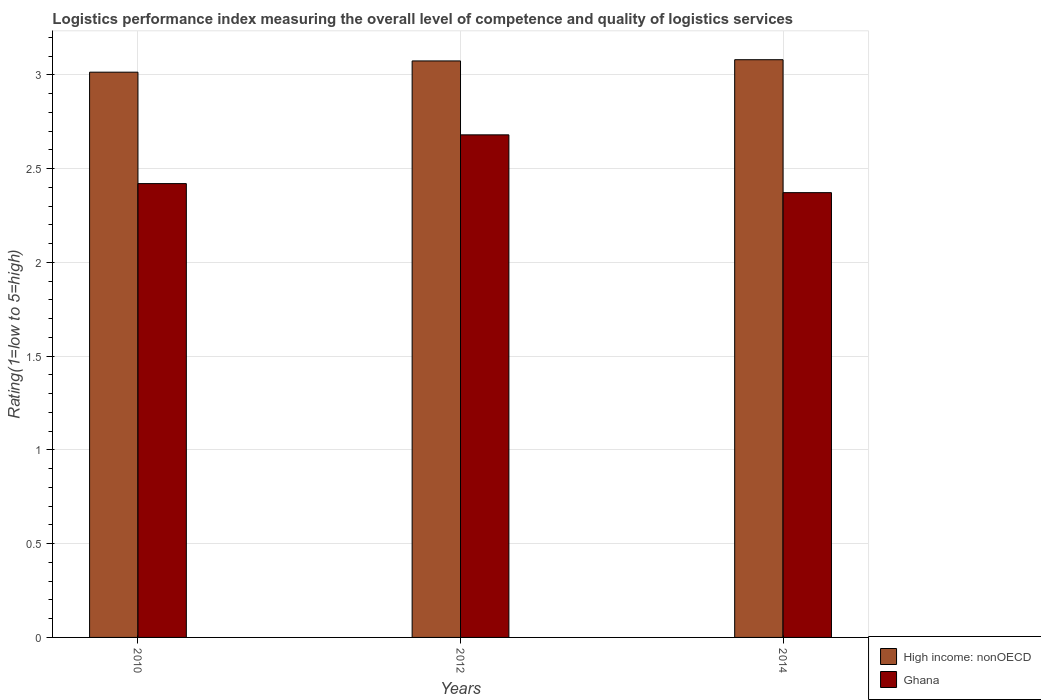Are the number of bars per tick equal to the number of legend labels?
Give a very brief answer. Yes. What is the Logistic performance index in High income: nonOECD in 2010?
Offer a very short reply. 3.01. Across all years, what is the maximum Logistic performance index in Ghana?
Offer a very short reply. 2.68. Across all years, what is the minimum Logistic performance index in Ghana?
Offer a terse response. 2.37. In which year was the Logistic performance index in Ghana minimum?
Provide a short and direct response. 2014. What is the total Logistic performance index in Ghana in the graph?
Make the answer very short. 7.47. What is the difference between the Logistic performance index in High income: nonOECD in 2010 and that in 2012?
Offer a terse response. -0.06. What is the difference between the Logistic performance index in High income: nonOECD in 2010 and the Logistic performance index in Ghana in 2014?
Provide a short and direct response. 0.64. What is the average Logistic performance index in Ghana per year?
Ensure brevity in your answer.  2.49. In the year 2012, what is the difference between the Logistic performance index in High income: nonOECD and Logistic performance index in Ghana?
Make the answer very short. 0.39. In how many years, is the Logistic performance index in High income: nonOECD greater than 2.7?
Your response must be concise. 3. What is the ratio of the Logistic performance index in High income: nonOECD in 2012 to that in 2014?
Make the answer very short. 1. Is the difference between the Logistic performance index in High income: nonOECD in 2010 and 2012 greater than the difference between the Logistic performance index in Ghana in 2010 and 2012?
Provide a short and direct response. Yes. What is the difference between the highest and the second highest Logistic performance index in High income: nonOECD?
Provide a short and direct response. 0.01. What is the difference between the highest and the lowest Logistic performance index in High income: nonOECD?
Your answer should be very brief. 0.07. In how many years, is the Logistic performance index in Ghana greater than the average Logistic performance index in Ghana taken over all years?
Your answer should be compact. 1. Is the sum of the Logistic performance index in Ghana in 2010 and 2014 greater than the maximum Logistic performance index in High income: nonOECD across all years?
Your answer should be compact. Yes. What does the 2nd bar from the right in 2010 represents?
Make the answer very short. High income: nonOECD. How many bars are there?
Give a very brief answer. 6. How many years are there in the graph?
Provide a short and direct response. 3. Does the graph contain any zero values?
Your answer should be very brief. No. How are the legend labels stacked?
Your answer should be very brief. Vertical. What is the title of the graph?
Provide a short and direct response. Logistics performance index measuring the overall level of competence and quality of logistics services. What is the label or title of the X-axis?
Offer a very short reply. Years. What is the label or title of the Y-axis?
Your answer should be compact. Rating(1=low to 5=high). What is the Rating(1=low to 5=high) in High income: nonOECD in 2010?
Keep it short and to the point. 3.01. What is the Rating(1=low to 5=high) in Ghana in 2010?
Your answer should be compact. 2.42. What is the Rating(1=low to 5=high) of High income: nonOECD in 2012?
Your answer should be compact. 3.07. What is the Rating(1=low to 5=high) in Ghana in 2012?
Your answer should be very brief. 2.68. What is the Rating(1=low to 5=high) of High income: nonOECD in 2014?
Ensure brevity in your answer.  3.08. What is the Rating(1=low to 5=high) in Ghana in 2014?
Your answer should be compact. 2.37. Across all years, what is the maximum Rating(1=low to 5=high) in High income: nonOECD?
Provide a succinct answer. 3.08. Across all years, what is the maximum Rating(1=low to 5=high) in Ghana?
Give a very brief answer. 2.68. Across all years, what is the minimum Rating(1=low to 5=high) in High income: nonOECD?
Offer a very short reply. 3.01. Across all years, what is the minimum Rating(1=low to 5=high) in Ghana?
Offer a terse response. 2.37. What is the total Rating(1=low to 5=high) of High income: nonOECD in the graph?
Your response must be concise. 9.17. What is the total Rating(1=low to 5=high) in Ghana in the graph?
Give a very brief answer. 7.47. What is the difference between the Rating(1=low to 5=high) of High income: nonOECD in 2010 and that in 2012?
Your answer should be compact. -0.06. What is the difference between the Rating(1=low to 5=high) of Ghana in 2010 and that in 2012?
Make the answer very short. -0.26. What is the difference between the Rating(1=low to 5=high) in High income: nonOECD in 2010 and that in 2014?
Offer a very short reply. -0.07. What is the difference between the Rating(1=low to 5=high) in Ghana in 2010 and that in 2014?
Keep it short and to the point. 0.05. What is the difference between the Rating(1=low to 5=high) in High income: nonOECD in 2012 and that in 2014?
Keep it short and to the point. -0.01. What is the difference between the Rating(1=low to 5=high) of Ghana in 2012 and that in 2014?
Provide a succinct answer. 0.31. What is the difference between the Rating(1=low to 5=high) in High income: nonOECD in 2010 and the Rating(1=low to 5=high) in Ghana in 2012?
Provide a short and direct response. 0.33. What is the difference between the Rating(1=low to 5=high) of High income: nonOECD in 2010 and the Rating(1=low to 5=high) of Ghana in 2014?
Offer a terse response. 0.64. What is the difference between the Rating(1=low to 5=high) of High income: nonOECD in 2012 and the Rating(1=low to 5=high) of Ghana in 2014?
Keep it short and to the point. 0.7. What is the average Rating(1=low to 5=high) of High income: nonOECD per year?
Offer a very short reply. 3.06. What is the average Rating(1=low to 5=high) of Ghana per year?
Your answer should be compact. 2.49. In the year 2010, what is the difference between the Rating(1=low to 5=high) in High income: nonOECD and Rating(1=low to 5=high) in Ghana?
Make the answer very short. 0.59. In the year 2012, what is the difference between the Rating(1=low to 5=high) of High income: nonOECD and Rating(1=low to 5=high) of Ghana?
Your answer should be very brief. 0.39. In the year 2014, what is the difference between the Rating(1=low to 5=high) in High income: nonOECD and Rating(1=low to 5=high) in Ghana?
Your answer should be very brief. 0.71. What is the ratio of the Rating(1=low to 5=high) of High income: nonOECD in 2010 to that in 2012?
Keep it short and to the point. 0.98. What is the ratio of the Rating(1=low to 5=high) in Ghana in 2010 to that in 2012?
Your response must be concise. 0.9. What is the ratio of the Rating(1=low to 5=high) of High income: nonOECD in 2010 to that in 2014?
Keep it short and to the point. 0.98. What is the ratio of the Rating(1=low to 5=high) in Ghana in 2010 to that in 2014?
Your response must be concise. 1.02. What is the ratio of the Rating(1=low to 5=high) in Ghana in 2012 to that in 2014?
Provide a succinct answer. 1.13. What is the difference between the highest and the second highest Rating(1=low to 5=high) of High income: nonOECD?
Offer a terse response. 0.01. What is the difference between the highest and the second highest Rating(1=low to 5=high) in Ghana?
Offer a terse response. 0.26. What is the difference between the highest and the lowest Rating(1=low to 5=high) in High income: nonOECD?
Provide a succinct answer. 0.07. What is the difference between the highest and the lowest Rating(1=low to 5=high) of Ghana?
Keep it short and to the point. 0.31. 